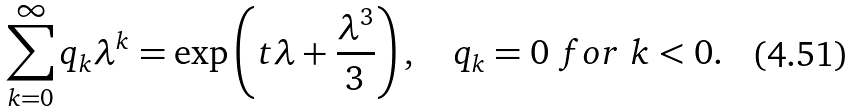Convert formula to latex. <formula><loc_0><loc_0><loc_500><loc_500>\sum _ { k = 0 } ^ { \infty } q _ { k } \lambda ^ { k } = \exp \left ( t \lambda + \frac { \lambda ^ { 3 } } { 3 } \right ) , \quad q _ { k } = 0 \ f o r \ k < 0 .</formula> 